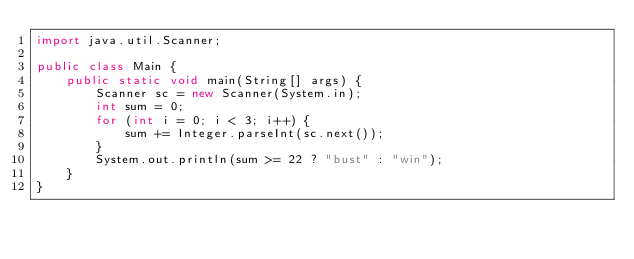Convert code to text. <code><loc_0><loc_0><loc_500><loc_500><_Java_>import java.util.Scanner;

public class Main {
    public static void main(String[] args) {
        Scanner sc = new Scanner(System.in);
        int sum = 0;
        for (int i = 0; i < 3; i++) {
            sum += Integer.parseInt(sc.next());
        }
        System.out.println(sum >= 22 ? "bust" : "win");
    }
}
</code> 